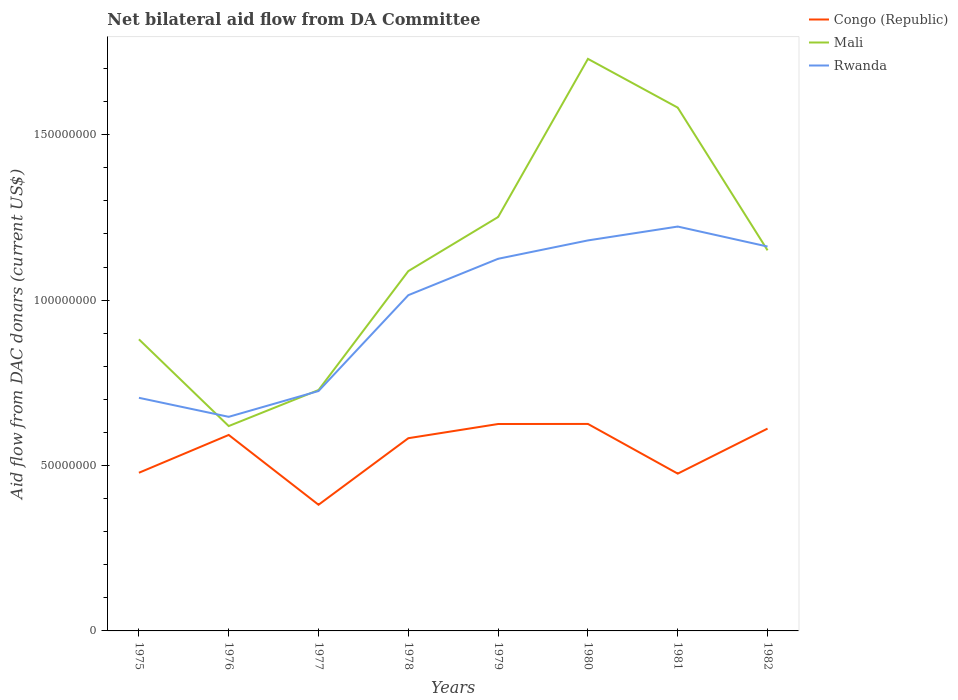Does the line corresponding to Mali intersect with the line corresponding to Rwanda?
Provide a short and direct response. Yes. Is the number of lines equal to the number of legend labels?
Your response must be concise. Yes. Across all years, what is the maximum aid flow in in Mali?
Your answer should be compact. 6.19e+07. In which year was the aid flow in in Congo (Republic) maximum?
Keep it short and to the point. 1977. What is the total aid flow in in Congo (Republic) in the graph?
Give a very brief answer. 2.11e+07. What is the difference between the highest and the second highest aid flow in in Mali?
Ensure brevity in your answer.  1.11e+08. What is the difference between the highest and the lowest aid flow in in Congo (Republic)?
Your answer should be very brief. 5. How many lines are there?
Your answer should be very brief. 3. What is the difference between two consecutive major ticks on the Y-axis?
Offer a very short reply. 5.00e+07. Are the values on the major ticks of Y-axis written in scientific E-notation?
Give a very brief answer. No. Does the graph contain grids?
Keep it short and to the point. No. What is the title of the graph?
Your answer should be compact. Net bilateral aid flow from DA Committee. Does "Sri Lanka" appear as one of the legend labels in the graph?
Your answer should be very brief. No. What is the label or title of the Y-axis?
Ensure brevity in your answer.  Aid flow from DAC donars (current US$). What is the Aid flow from DAC donars (current US$) in Congo (Republic) in 1975?
Give a very brief answer. 4.78e+07. What is the Aid flow from DAC donars (current US$) of Mali in 1975?
Offer a very short reply. 8.82e+07. What is the Aid flow from DAC donars (current US$) of Rwanda in 1975?
Give a very brief answer. 7.05e+07. What is the Aid flow from DAC donars (current US$) in Congo (Republic) in 1976?
Your answer should be compact. 5.92e+07. What is the Aid flow from DAC donars (current US$) in Mali in 1976?
Keep it short and to the point. 6.19e+07. What is the Aid flow from DAC donars (current US$) of Rwanda in 1976?
Your answer should be compact. 6.47e+07. What is the Aid flow from DAC donars (current US$) of Congo (Republic) in 1977?
Offer a very short reply. 3.81e+07. What is the Aid flow from DAC donars (current US$) of Mali in 1977?
Give a very brief answer. 7.28e+07. What is the Aid flow from DAC donars (current US$) of Rwanda in 1977?
Your response must be concise. 7.25e+07. What is the Aid flow from DAC donars (current US$) in Congo (Republic) in 1978?
Offer a terse response. 5.83e+07. What is the Aid flow from DAC donars (current US$) in Mali in 1978?
Your answer should be compact. 1.09e+08. What is the Aid flow from DAC donars (current US$) in Rwanda in 1978?
Offer a very short reply. 1.02e+08. What is the Aid flow from DAC donars (current US$) of Congo (Republic) in 1979?
Offer a terse response. 6.26e+07. What is the Aid flow from DAC donars (current US$) of Mali in 1979?
Make the answer very short. 1.25e+08. What is the Aid flow from DAC donars (current US$) of Rwanda in 1979?
Make the answer very short. 1.12e+08. What is the Aid flow from DAC donars (current US$) of Congo (Republic) in 1980?
Keep it short and to the point. 6.26e+07. What is the Aid flow from DAC donars (current US$) in Mali in 1980?
Your answer should be compact. 1.73e+08. What is the Aid flow from DAC donars (current US$) in Rwanda in 1980?
Offer a terse response. 1.18e+08. What is the Aid flow from DAC donars (current US$) of Congo (Republic) in 1981?
Give a very brief answer. 4.76e+07. What is the Aid flow from DAC donars (current US$) in Mali in 1981?
Offer a terse response. 1.58e+08. What is the Aid flow from DAC donars (current US$) in Rwanda in 1981?
Give a very brief answer. 1.22e+08. What is the Aid flow from DAC donars (current US$) in Congo (Republic) in 1982?
Your answer should be very brief. 6.12e+07. What is the Aid flow from DAC donars (current US$) in Mali in 1982?
Give a very brief answer. 1.15e+08. What is the Aid flow from DAC donars (current US$) in Rwanda in 1982?
Your answer should be compact. 1.16e+08. Across all years, what is the maximum Aid flow from DAC donars (current US$) of Congo (Republic)?
Provide a short and direct response. 6.26e+07. Across all years, what is the maximum Aid flow from DAC donars (current US$) in Mali?
Your response must be concise. 1.73e+08. Across all years, what is the maximum Aid flow from DAC donars (current US$) of Rwanda?
Ensure brevity in your answer.  1.22e+08. Across all years, what is the minimum Aid flow from DAC donars (current US$) in Congo (Republic)?
Make the answer very short. 3.81e+07. Across all years, what is the minimum Aid flow from DAC donars (current US$) of Mali?
Give a very brief answer. 6.19e+07. Across all years, what is the minimum Aid flow from DAC donars (current US$) in Rwanda?
Your answer should be compact. 6.47e+07. What is the total Aid flow from DAC donars (current US$) of Congo (Republic) in the graph?
Make the answer very short. 4.37e+08. What is the total Aid flow from DAC donars (current US$) of Mali in the graph?
Provide a succinct answer. 9.03e+08. What is the total Aid flow from DAC donars (current US$) in Rwanda in the graph?
Provide a succinct answer. 7.78e+08. What is the difference between the Aid flow from DAC donars (current US$) of Congo (Republic) in 1975 and that in 1976?
Ensure brevity in your answer.  -1.14e+07. What is the difference between the Aid flow from DAC donars (current US$) of Mali in 1975 and that in 1976?
Ensure brevity in your answer.  2.62e+07. What is the difference between the Aid flow from DAC donars (current US$) of Rwanda in 1975 and that in 1976?
Ensure brevity in your answer.  5.75e+06. What is the difference between the Aid flow from DAC donars (current US$) in Congo (Republic) in 1975 and that in 1977?
Your response must be concise. 9.67e+06. What is the difference between the Aid flow from DAC donars (current US$) of Mali in 1975 and that in 1977?
Give a very brief answer. 1.53e+07. What is the difference between the Aid flow from DAC donars (current US$) of Rwanda in 1975 and that in 1977?
Offer a terse response. -2.05e+06. What is the difference between the Aid flow from DAC donars (current US$) in Congo (Republic) in 1975 and that in 1978?
Make the answer very short. -1.04e+07. What is the difference between the Aid flow from DAC donars (current US$) in Mali in 1975 and that in 1978?
Your answer should be compact. -2.06e+07. What is the difference between the Aid flow from DAC donars (current US$) in Rwanda in 1975 and that in 1978?
Give a very brief answer. -3.10e+07. What is the difference between the Aid flow from DAC donars (current US$) in Congo (Republic) in 1975 and that in 1979?
Offer a very short reply. -1.47e+07. What is the difference between the Aid flow from DAC donars (current US$) in Mali in 1975 and that in 1979?
Give a very brief answer. -3.70e+07. What is the difference between the Aid flow from DAC donars (current US$) of Rwanda in 1975 and that in 1979?
Offer a very short reply. -4.20e+07. What is the difference between the Aid flow from DAC donars (current US$) in Congo (Republic) in 1975 and that in 1980?
Make the answer very short. -1.48e+07. What is the difference between the Aid flow from DAC donars (current US$) of Mali in 1975 and that in 1980?
Ensure brevity in your answer.  -8.48e+07. What is the difference between the Aid flow from DAC donars (current US$) of Rwanda in 1975 and that in 1980?
Provide a short and direct response. -4.76e+07. What is the difference between the Aid flow from DAC donars (current US$) in Mali in 1975 and that in 1981?
Offer a terse response. -7.00e+07. What is the difference between the Aid flow from DAC donars (current US$) in Rwanda in 1975 and that in 1981?
Ensure brevity in your answer.  -5.18e+07. What is the difference between the Aid flow from DAC donars (current US$) of Congo (Republic) in 1975 and that in 1982?
Keep it short and to the point. -1.34e+07. What is the difference between the Aid flow from DAC donars (current US$) of Mali in 1975 and that in 1982?
Your answer should be compact. -2.69e+07. What is the difference between the Aid flow from DAC donars (current US$) of Rwanda in 1975 and that in 1982?
Your response must be concise. -4.57e+07. What is the difference between the Aid flow from DAC donars (current US$) in Congo (Republic) in 1976 and that in 1977?
Provide a succinct answer. 2.11e+07. What is the difference between the Aid flow from DAC donars (current US$) in Mali in 1976 and that in 1977?
Your answer should be very brief. -1.09e+07. What is the difference between the Aid flow from DAC donars (current US$) of Rwanda in 1976 and that in 1977?
Keep it short and to the point. -7.80e+06. What is the difference between the Aid flow from DAC donars (current US$) in Congo (Republic) in 1976 and that in 1978?
Your answer should be very brief. 9.80e+05. What is the difference between the Aid flow from DAC donars (current US$) of Mali in 1976 and that in 1978?
Give a very brief answer. -4.68e+07. What is the difference between the Aid flow from DAC donars (current US$) of Rwanda in 1976 and that in 1978?
Provide a short and direct response. -3.68e+07. What is the difference between the Aid flow from DAC donars (current US$) in Congo (Republic) in 1976 and that in 1979?
Make the answer very short. -3.31e+06. What is the difference between the Aid flow from DAC donars (current US$) in Mali in 1976 and that in 1979?
Provide a succinct answer. -6.32e+07. What is the difference between the Aid flow from DAC donars (current US$) in Rwanda in 1976 and that in 1979?
Offer a terse response. -4.78e+07. What is the difference between the Aid flow from DAC donars (current US$) in Congo (Republic) in 1976 and that in 1980?
Make the answer very short. -3.33e+06. What is the difference between the Aid flow from DAC donars (current US$) in Mali in 1976 and that in 1980?
Offer a terse response. -1.11e+08. What is the difference between the Aid flow from DAC donars (current US$) of Rwanda in 1976 and that in 1980?
Your answer should be very brief. -5.33e+07. What is the difference between the Aid flow from DAC donars (current US$) in Congo (Republic) in 1976 and that in 1981?
Offer a terse response. 1.17e+07. What is the difference between the Aid flow from DAC donars (current US$) in Mali in 1976 and that in 1981?
Make the answer very short. -9.63e+07. What is the difference between the Aid flow from DAC donars (current US$) of Rwanda in 1976 and that in 1981?
Your response must be concise. -5.75e+07. What is the difference between the Aid flow from DAC donars (current US$) in Congo (Republic) in 1976 and that in 1982?
Provide a short and direct response. -1.92e+06. What is the difference between the Aid flow from DAC donars (current US$) of Mali in 1976 and that in 1982?
Your answer should be compact. -5.31e+07. What is the difference between the Aid flow from DAC donars (current US$) in Rwanda in 1976 and that in 1982?
Make the answer very short. -5.15e+07. What is the difference between the Aid flow from DAC donars (current US$) in Congo (Republic) in 1977 and that in 1978?
Ensure brevity in your answer.  -2.01e+07. What is the difference between the Aid flow from DAC donars (current US$) of Mali in 1977 and that in 1978?
Your answer should be very brief. -3.60e+07. What is the difference between the Aid flow from DAC donars (current US$) of Rwanda in 1977 and that in 1978?
Provide a succinct answer. -2.90e+07. What is the difference between the Aid flow from DAC donars (current US$) in Congo (Republic) in 1977 and that in 1979?
Make the answer very short. -2.44e+07. What is the difference between the Aid flow from DAC donars (current US$) of Mali in 1977 and that in 1979?
Provide a succinct answer. -5.23e+07. What is the difference between the Aid flow from DAC donars (current US$) of Rwanda in 1977 and that in 1979?
Offer a very short reply. -4.00e+07. What is the difference between the Aid flow from DAC donars (current US$) of Congo (Republic) in 1977 and that in 1980?
Make the answer very short. -2.44e+07. What is the difference between the Aid flow from DAC donars (current US$) of Mali in 1977 and that in 1980?
Ensure brevity in your answer.  -1.00e+08. What is the difference between the Aid flow from DAC donars (current US$) of Rwanda in 1977 and that in 1980?
Provide a short and direct response. -4.55e+07. What is the difference between the Aid flow from DAC donars (current US$) in Congo (Republic) in 1977 and that in 1981?
Your response must be concise. -9.41e+06. What is the difference between the Aid flow from DAC donars (current US$) in Mali in 1977 and that in 1981?
Offer a terse response. -8.54e+07. What is the difference between the Aid flow from DAC donars (current US$) in Rwanda in 1977 and that in 1981?
Offer a very short reply. -4.97e+07. What is the difference between the Aid flow from DAC donars (current US$) in Congo (Republic) in 1977 and that in 1982?
Keep it short and to the point. -2.30e+07. What is the difference between the Aid flow from DAC donars (current US$) in Mali in 1977 and that in 1982?
Offer a very short reply. -4.22e+07. What is the difference between the Aid flow from DAC donars (current US$) of Rwanda in 1977 and that in 1982?
Provide a succinct answer. -4.37e+07. What is the difference between the Aid flow from DAC donars (current US$) in Congo (Republic) in 1978 and that in 1979?
Your response must be concise. -4.29e+06. What is the difference between the Aid flow from DAC donars (current US$) in Mali in 1978 and that in 1979?
Offer a terse response. -1.64e+07. What is the difference between the Aid flow from DAC donars (current US$) in Rwanda in 1978 and that in 1979?
Give a very brief answer. -1.10e+07. What is the difference between the Aid flow from DAC donars (current US$) of Congo (Republic) in 1978 and that in 1980?
Your response must be concise. -4.31e+06. What is the difference between the Aid flow from DAC donars (current US$) of Mali in 1978 and that in 1980?
Offer a terse response. -6.42e+07. What is the difference between the Aid flow from DAC donars (current US$) of Rwanda in 1978 and that in 1980?
Give a very brief answer. -1.66e+07. What is the difference between the Aid flow from DAC donars (current US$) of Congo (Republic) in 1978 and that in 1981?
Offer a very short reply. 1.07e+07. What is the difference between the Aid flow from DAC donars (current US$) in Mali in 1978 and that in 1981?
Ensure brevity in your answer.  -4.94e+07. What is the difference between the Aid flow from DAC donars (current US$) of Rwanda in 1978 and that in 1981?
Make the answer very short. -2.07e+07. What is the difference between the Aid flow from DAC donars (current US$) of Congo (Republic) in 1978 and that in 1982?
Your answer should be very brief. -2.90e+06. What is the difference between the Aid flow from DAC donars (current US$) of Mali in 1978 and that in 1982?
Offer a terse response. -6.27e+06. What is the difference between the Aid flow from DAC donars (current US$) in Rwanda in 1978 and that in 1982?
Offer a very short reply. -1.47e+07. What is the difference between the Aid flow from DAC donars (current US$) in Mali in 1979 and that in 1980?
Offer a terse response. -4.78e+07. What is the difference between the Aid flow from DAC donars (current US$) in Rwanda in 1979 and that in 1980?
Your response must be concise. -5.55e+06. What is the difference between the Aid flow from DAC donars (current US$) of Congo (Republic) in 1979 and that in 1981?
Give a very brief answer. 1.50e+07. What is the difference between the Aid flow from DAC donars (current US$) of Mali in 1979 and that in 1981?
Your response must be concise. -3.31e+07. What is the difference between the Aid flow from DAC donars (current US$) of Rwanda in 1979 and that in 1981?
Ensure brevity in your answer.  -9.74e+06. What is the difference between the Aid flow from DAC donars (current US$) of Congo (Republic) in 1979 and that in 1982?
Your response must be concise. 1.39e+06. What is the difference between the Aid flow from DAC donars (current US$) in Mali in 1979 and that in 1982?
Your response must be concise. 1.01e+07. What is the difference between the Aid flow from DAC donars (current US$) of Rwanda in 1979 and that in 1982?
Make the answer very short. -3.70e+06. What is the difference between the Aid flow from DAC donars (current US$) of Congo (Republic) in 1980 and that in 1981?
Your response must be concise. 1.50e+07. What is the difference between the Aid flow from DAC donars (current US$) in Mali in 1980 and that in 1981?
Ensure brevity in your answer.  1.47e+07. What is the difference between the Aid flow from DAC donars (current US$) in Rwanda in 1980 and that in 1981?
Your response must be concise. -4.19e+06. What is the difference between the Aid flow from DAC donars (current US$) of Congo (Republic) in 1980 and that in 1982?
Your answer should be compact. 1.41e+06. What is the difference between the Aid flow from DAC donars (current US$) in Mali in 1980 and that in 1982?
Keep it short and to the point. 5.79e+07. What is the difference between the Aid flow from DAC donars (current US$) in Rwanda in 1980 and that in 1982?
Provide a short and direct response. 1.85e+06. What is the difference between the Aid flow from DAC donars (current US$) in Congo (Republic) in 1981 and that in 1982?
Provide a succinct answer. -1.36e+07. What is the difference between the Aid flow from DAC donars (current US$) of Mali in 1981 and that in 1982?
Make the answer very short. 4.31e+07. What is the difference between the Aid flow from DAC donars (current US$) of Rwanda in 1981 and that in 1982?
Give a very brief answer. 6.04e+06. What is the difference between the Aid flow from DAC donars (current US$) in Congo (Republic) in 1975 and the Aid flow from DAC donars (current US$) in Mali in 1976?
Offer a terse response. -1.41e+07. What is the difference between the Aid flow from DAC donars (current US$) of Congo (Republic) in 1975 and the Aid flow from DAC donars (current US$) of Rwanda in 1976?
Give a very brief answer. -1.69e+07. What is the difference between the Aid flow from DAC donars (current US$) in Mali in 1975 and the Aid flow from DAC donars (current US$) in Rwanda in 1976?
Your answer should be very brief. 2.34e+07. What is the difference between the Aid flow from DAC donars (current US$) in Congo (Republic) in 1975 and the Aid flow from DAC donars (current US$) in Mali in 1977?
Give a very brief answer. -2.50e+07. What is the difference between the Aid flow from DAC donars (current US$) of Congo (Republic) in 1975 and the Aid flow from DAC donars (current US$) of Rwanda in 1977?
Your answer should be very brief. -2.47e+07. What is the difference between the Aid flow from DAC donars (current US$) of Mali in 1975 and the Aid flow from DAC donars (current US$) of Rwanda in 1977?
Provide a short and direct response. 1.56e+07. What is the difference between the Aid flow from DAC donars (current US$) in Congo (Republic) in 1975 and the Aid flow from DAC donars (current US$) in Mali in 1978?
Your answer should be very brief. -6.10e+07. What is the difference between the Aid flow from DAC donars (current US$) in Congo (Republic) in 1975 and the Aid flow from DAC donars (current US$) in Rwanda in 1978?
Keep it short and to the point. -5.37e+07. What is the difference between the Aid flow from DAC donars (current US$) in Mali in 1975 and the Aid flow from DAC donars (current US$) in Rwanda in 1978?
Your response must be concise. -1.34e+07. What is the difference between the Aid flow from DAC donars (current US$) in Congo (Republic) in 1975 and the Aid flow from DAC donars (current US$) in Mali in 1979?
Keep it short and to the point. -7.73e+07. What is the difference between the Aid flow from DAC donars (current US$) in Congo (Republic) in 1975 and the Aid flow from DAC donars (current US$) in Rwanda in 1979?
Ensure brevity in your answer.  -6.47e+07. What is the difference between the Aid flow from DAC donars (current US$) of Mali in 1975 and the Aid flow from DAC donars (current US$) of Rwanda in 1979?
Keep it short and to the point. -2.44e+07. What is the difference between the Aid flow from DAC donars (current US$) in Congo (Republic) in 1975 and the Aid flow from DAC donars (current US$) in Mali in 1980?
Your response must be concise. -1.25e+08. What is the difference between the Aid flow from DAC donars (current US$) in Congo (Republic) in 1975 and the Aid flow from DAC donars (current US$) in Rwanda in 1980?
Your response must be concise. -7.02e+07. What is the difference between the Aid flow from DAC donars (current US$) in Mali in 1975 and the Aid flow from DAC donars (current US$) in Rwanda in 1980?
Offer a terse response. -2.99e+07. What is the difference between the Aid flow from DAC donars (current US$) of Congo (Republic) in 1975 and the Aid flow from DAC donars (current US$) of Mali in 1981?
Provide a short and direct response. -1.10e+08. What is the difference between the Aid flow from DAC donars (current US$) of Congo (Republic) in 1975 and the Aid flow from DAC donars (current US$) of Rwanda in 1981?
Your response must be concise. -7.44e+07. What is the difference between the Aid flow from DAC donars (current US$) of Mali in 1975 and the Aid flow from DAC donars (current US$) of Rwanda in 1981?
Give a very brief answer. -3.41e+07. What is the difference between the Aid flow from DAC donars (current US$) in Congo (Republic) in 1975 and the Aid flow from DAC donars (current US$) in Mali in 1982?
Keep it short and to the point. -6.72e+07. What is the difference between the Aid flow from DAC donars (current US$) in Congo (Republic) in 1975 and the Aid flow from DAC donars (current US$) in Rwanda in 1982?
Offer a very short reply. -6.84e+07. What is the difference between the Aid flow from DAC donars (current US$) of Mali in 1975 and the Aid flow from DAC donars (current US$) of Rwanda in 1982?
Offer a very short reply. -2.80e+07. What is the difference between the Aid flow from DAC donars (current US$) of Congo (Republic) in 1976 and the Aid flow from DAC donars (current US$) of Mali in 1977?
Provide a succinct answer. -1.36e+07. What is the difference between the Aid flow from DAC donars (current US$) of Congo (Republic) in 1976 and the Aid flow from DAC donars (current US$) of Rwanda in 1977?
Provide a succinct answer. -1.33e+07. What is the difference between the Aid flow from DAC donars (current US$) of Mali in 1976 and the Aid flow from DAC donars (current US$) of Rwanda in 1977?
Offer a terse response. -1.06e+07. What is the difference between the Aid flow from DAC donars (current US$) of Congo (Republic) in 1976 and the Aid flow from DAC donars (current US$) of Mali in 1978?
Offer a terse response. -4.95e+07. What is the difference between the Aid flow from DAC donars (current US$) of Congo (Republic) in 1976 and the Aid flow from DAC donars (current US$) of Rwanda in 1978?
Keep it short and to the point. -4.23e+07. What is the difference between the Aid flow from DAC donars (current US$) in Mali in 1976 and the Aid flow from DAC donars (current US$) in Rwanda in 1978?
Offer a very short reply. -3.96e+07. What is the difference between the Aid flow from DAC donars (current US$) in Congo (Republic) in 1976 and the Aid flow from DAC donars (current US$) in Mali in 1979?
Provide a succinct answer. -6.59e+07. What is the difference between the Aid flow from DAC donars (current US$) of Congo (Republic) in 1976 and the Aid flow from DAC donars (current US$) of Rwanda in 1979?
Your response must be concise. -5.33e+07. What is the difference between the Aid flow from DAC donars (current US$) in Mali in 1976 and the Aid flow from DAC donars (current US$) in Rwanda in 1979?
Offer a very short reply. -5.06e+07. What is the difference between the Aid flow from DAC donars (current US$) in Congo (Republic) in 1976 and the Aid flow from DAC donars (current US$) in Mali in 1980?
Keep it short and to the point. -1.14e+08. What is the difference between the Aid flow from DAC donars (current US$) of Congo (Republic) in 1976 and the Aid flow from DAC donars (current US$) of Rwanda in 1980?
Your answer should be compact. -5.88e+07. What is the difference between the Aid flow from DAC donars (current US$) of Mali in 1976 and the Aid flow from DAC donars (current US$) of Rwanda in 1980?
Provide a short and direct response. -5.61e+07. What is the difference between the Aid flow from DAC donars (current US$) in Congo (Republic) in 1976 and the Aid flow from DAC donars (current US$) in Mali in 1981?
Provide a succinct answer. -9.90e+07. What is the difference between the Aid flow from DAC donars (current US$) in Congo (Republic) in 1976 and the Aid flow from DAC donars (current US$) in Rwanda in 1981?
Give a very brief answer. -6.30e+07. What is the difference between the Aid flow from DAC donars (current US$) of Mali in 1976 and the Aid flow from DAC donars (current US$) of Rwanda in 1981?
Offer a very short reply. -6.03e+07. What is the difference between the Aid flow from DAC donars (current US$) of Congo (Republic) in 1976 and the Aid flow from DAC donars (current US$) of Mali in 1982?
Offer a very short reply. -5.58e+07. What is the difference between the Aid flow from DAC donars (current US$) of Congo (Republic) in 1976 and the Aid flow from DAC donars (current US$) of Rwanda in 1982?
Give a very brief answer. -5.70e+07. What is the difference between the Aid flow from DAC donars (current US$) of Mali in 1976 and the Aid flow from DAC donars (current US$) of Rwanda in 1982?
Offer a very short reply. -5.43e+07. What is the difference between the Aid flow from DAC donars (current US$) in Congo (Republic) in 1977 and the Aid flow from DAC donars (current US$) in Mali in 1978?
Your answer should be compact. -7.06e+07. What is the difference between the Aid flow from DAC donars (current US$) of Congo (Republic) in 1977 and the Aid flow from DAC donars (current US$) of Rwanda in 1978?
Provide a succinct answer. -6.34e+07. What is the difference between the Aid flow from DAC donars (current US$) in Mali in 1977 and the Aid flow from DAC donars (current US$) in Rwanda in 1978?
Keep it short and to the point. -2.87e+07. What is the difference between the Aid flow from DAC donars (current US$) of Congo (Republic) in 1977 and the Aid flow from DAC donars (current US$) of Mali in 1979?
Keep it short and to the point. -8.70e+07. What is the difference between the Aid flow from DAC donars (current US$) of Congo (Republic) in 1977 and the Aid flow from DAC donars (current US$) of Rwanda in 1979?
Offer a very short reply. -7.44e+07. What is the difference between the Aid flow from DAC donars (current US$) of Mali in 1977 and the Aid flow from DAC donars (current US$) of Rwanda in 1979?
Ensure brevity in your answer.  -3.97e+07. What is the difference between the Aid flow from DAC donars (current US$) in Congo (Republic) in 1977 and the Aid flow from DAC donars (current US$) in Mali in 1980?
Your response must be concise. -1.35e+08. What is the difference between the Aid flow from DAC donars (current US$) in Congo (Republic) in 1977 and the Aid flow from DAC donars (current US$) in Rwanda in 1980?
Keep it short and to the point. -7.99e+07. What is the difference between the Aid flow from DAC donars (current US$) in Mali in 1977 and the Aid flow from DAC donars (current US$) in Rwanda in 1980?
Ensure brevity in your answer.  -4.52e+07. What is the difference between the Aid flow from DAC donars (current US$) in Congo (Republic) in 1977 and the Aid flow from DAC donars (current US$) in Mali in 1981?
Provide a succinct answer. -1.20e+08. What is the difference between the Aid flow from DAC donars (current US$) in Congo (Republic) in 1977 and the Aid flow from DAC donars (current US$) in Rwanda in 1981?
Make the answer very short. -8.41e+07. What is the difference between the Aid flow from DAC donars (current US$) of Mali in 1977 and the Aid flow from DAC donars (current US$) of Rwanda in 1981?
Offer a very short reply. -4.94e+07. What is the difference between the Aid flow from DAC donars (current US$) in Congo (Republic) in 1977 and the Aid flow from DAC donars (current US$) in Mali in 1982?
Your response must be concise. -7.69e+07. What is the difference between the Aid flow from DAC donars (current US$) of Congo (Republic) in 1977 and the Aid flow from DAC donars (current US$) of Rwanda in 1982?
Offer a terse response. -7.81e+07. What is the difference between the Aid flow from DAC donars (current US$) of Mali in 1977 and the Aid flow from DAC donars (current US$) of Rwanda in 1982?
Offer a terse response. -4.34e+07. What is the difference between the Aid flow from DAC donars (current US$) of Congo (Republic) in 1978 and the Aid flow from DAC donars (current US$) of Mali in 1979?
Make the answer very short. -6.69e+07. What is the difference between the Aid flow from DAC donars (current US$) in Congo (Republic) in 1978 and the Aid flow from DAC donars (current US$) in Rwanda in 1979?
Give a very brief answer. -5.42e+07. What is the difference between the Aid flow from DAC donars (current US$) of Mali in 1978 and the Aid flow from DAC donars (current US$) of Rwanda in 1979?
Ensure brevity in your answer.  -3.72e+06. What is the difference between the Aid flow from DAC donars (current US$) of Congo (Republic) in 1978 and the Aid flow from DAC donars (current US$) of Mali in 1980?
Offer a very short reply. -1.15e+08. What is the difference between the Aid flow from DAC donars (current US$) in Congo (Republic) in 1978 and the Aid flow from DAC donars (current US$) in Rwanda in 1980?
Ensure brevity in your answer.  -5.98e+07. What is the difference between the Aid flow from DAC donars (current US$) of Mali in 1978 and the Aid flow from DAC donars (current US$) of Rwanda in 1980?
Make the answer very short. -9.27e+06. What is the difference between the Aid flow from DAC donars (current US$) in Congo (Republic) in 1978 and the Aid flow from DAC donars (current US$) in Mali in 1981?
Your answer should be compact. -9.99e+07. What is the difference between the Aid flow from DAC donars (current US$) in Congo (Republic) in 1978 and the Aid flow from DAC donars (current US$) in Rwanda in 1981?
Ensure brevity in your answer.  -6.40e+07. What is the difference between the Aid flow from DAC donars (current US$) in Mali in 1978 and the Aid flow from DAC donars (current US$) in Rwanda in 1981?
Offer a very short reply. -1.35e+07. What is the difference between the Aid flow from DAC donars (current US$) in Congo (Republic) in 1978 and the Aid flow from DAC donars (current US$) in Mali in 1982?
Provide a short and direct response. -5.68e+07. What is the difference between the Aid flow from DAC donars (current US$) in Congo (Republic) in 1978 and the Aid flow from DAC donars (current US$) in Rwanda in 1982?
Keep it short and to the point. -5.79e+07. What is the difference between the Aid flow from DAC donars (current US$) in Mali in 1978 and the Aid flow from DAC donars (current US$) in Rwanda in 1982?
Offer a very short reply. -7.42e+06. What is the difference between the Aid flow from DAC donars (current US$) in Congo (Republic) in 1979 and the Aid flow from DAC donars (current US$) in Mali in 1980?
Offer a very short reply. -1.10e+08. What is the difference between the Aid flow from DAC donars (current US$) of Congo (Republic) in 1979 and the Aid flow from DAC donars (current US$) of Rwanda in 1980?
Provide a short and direct response. -5.55e+07. What is the difference between the Aid flow from DAC donars (current US$) of Mali in 1979 and the Aid flow from DAC donars (current US$) of Rwanda in 1980?
Ensure brevity in your answer.  7.08e+06. What is the difference between the Aid flow from DAC donars (current US$) in Congo (Republic) in 1979 and the Aid flow from DAC donars (current US$) in Mali in 1981?
Your response must be concise. -9.56e+07. What is the difference between the Aid flow from DAC donars (current US$) of Congo (Republic) in 1979 and the Aid flow from DAC donars (current US$) of Rwanda in 1981?
Your answer should be very brief. -5.97e+07. What is the difference between the Aid flow from DAC donars (current US$) in Mali in 1979 and the Aid flow from DAC donars (current US$) in Rwanda in 1981?
Offer a very short reply. 2.89e+06. What is the difference between the Aid flow from DAC donars (current US$) of Congo (Republic) in 1979 and the Aid flow from DAC donars (current US$) of Mali in 1982?
Keep it short and to the point. -5.25e+07. What is the difference between the Aid flow from DAC donars (current US$) of Congo (Republic) in 1979 and the Aid flow from DAC donars (current US$) of Rwanda in 1982?
Make the answer very short. -5.36e+07. What is the difference between the Aid flow from DAC donars (current US$) in Mali in 1979 and the Aid flow from DAC donars (current US$) in Rwanda in 1982?
Your response must be concise. 8.93e+06. What is the difference between the Aid flow from DAC donars (current US$) in Congo (Republic) in 1980 and the Aid flow from DAC donars (current US$) in Mali in 1981?
Keep it short and to the point. -9.56e+07. What is the difference between the Aid flow from DAC donars (current US$) of Congo (Republic) in 1980 and the Aid flow from DAC donars (current US$) of Rwanda in 1981?
Offer a very short reply. -5.97e+07. What is the difference between the Aid flow from DAC donars (current US$) in Mali in 1980 and the Aid flow from DAC donars (current US$) in Rwanda in 1981?
Your answer should be compact. 5.07e+07. What is the difference between the Aid flow from DAC donars (current US$) of Congo (Republic) in 1980 and the Aid flow from DAC donars (current US$) of Mali in 1982?
Your answer should be compact. -5.25e+07. What is the difference between the Aid flow from DAC donars (current US$) in Congo (Republic) in 1980 and the Aid flow from DAC donars (current US$) in Rwanda in 1982?
Your response must be concise. -5.36e+07. What is the difference between the Aid flow from DAC donars (current US$) of Mali in 1980 and the Aid flow from DAC donars (current US$) of Rwanda in 1982?
Your answer should be very brief. 5.67e+07. What is the difference between the Aid flow from DAC donars (current US$) in Congo (Republic) in 1981 and the Aid flow from DAC donars (current US$) in Mali in 1982?
Provide a succinct answer. -6.75e+07. What is the difference between the Aid flow from DAC donars (current US$) of Congo (Republic) in 1981 and the Aid flow from DAC donars (current US$) of Rwanda in 1982?
Provide a short and direct response. -6.86e+07. What is the difference between the Aid flow from DAC donars (current US$) of Mali in 1981 and the Aid flow from DAC donars (current US$) of Rwanda in 1982?
Give a very brief answer. 4.20e+07. What is the average Aid flow from DAC donars (current US$) of Congo (Republic) per year?
Keep it short and to the point. 5.47e+07. What is the average Aid flow from DAC donars (current US$) of Mali per year?
Make the answer very short. 1.13e+08. What is the average Aid flow from DAC donars (current US$) in Rwanda per year?
Ensure brevity in your answer.  9.73e+07. In the year 1975, what is the difference between the Aid flow from DAC donars (current US$) in Congo (Republic) and Aid flow from DAC donars (current US$) in Mali?
Your answer should be very brief. -4.03e+07. In the year 1975, what is the difference between the Aid flow from DAC donars (current US$) in Congo (Republic) and Aid flow from DAC donars (current US$) in Rwanda?
Give a very brief answer. -2.27e+07. In the year 1975, what is the difference between the Aid flow from DAC donars (current US$) of Mali and Aid flow from DAC donars (current US$) of Rwanda?
Give a very brief answer. 1.77e+07. In the year 1976, what is the difference between the Aid flow from DAC donars (current US$) of Congo (Republic) and Aid flow from DAC donars (current US$) of Mali?
Ensure brevity in your answer.  -2.69e+06. In the year 1976, what is the difference between the Aid flow from DAC donars (current US$) of Congo (Republic) and Aid flow from DAC donars (current US$) of Rwanda?
Offer a terse response. -5.48e+06. In the year 1976, what is the difference between the Aid flow from DAC donars (current US$) in Mali and Aid flow from DAC donars (current US$) in Rwanda?
Offer a terse response. -2.79e+06. In the year 1977, what is the difference between the Aid flow from DAC donars (current US$) in Congo (Republic) and Aid flow from DAC donars (current US$) in Mali?
Give a very brief answer. -3.47e+07. In the year 1977, what is the difference between the Aid flow from DAC donars (current US$) in Congo (Republic) and Aid flow from DAC donars (current US$) in Rwanda?
Provide a succinct answer. -3.44e+07. In the year 1978, what is the difference between the Aid flow from DAC donars (current US$) in Congo (Republic) and Aid flow from DAC donars (current US$) in Mali?
Give a very brief answer. -5.05e+07. In the year 1978, what is the difference between the Aid flow from DAC donars (current US$) in Congo (Republic) and Aid flow from DAC donars (current US$) in Rwanda?
Provide a short and direct response. -4.32e+07. In the year 1978, what is the difference between the Aid flow from DAC donars (current US$) of Mali and Aid flow from DAC donars (current US$) of Rwanda?
Keep it short and to the point. 7.28e+06. In the year 1979, what is the difference between the Aid flow from DAC donars (current US$) in Congo (Republic) and Aid flow from DAC donars (current US$) in Mali?
Your answer should be very brief. -6.26e+07. In the year 1979, what is the difference between the Aid flow from DAC donars (current US$) in Congo (Republic) and Aid flow from DAC donars (current US$) in Rwanda?
Make the answer very short. -5.00e+07. In the year 1979, what is the difference between the Aid flow from DAC donars (current US$) in Mali and Aid flow from DAC donars (current US$) in Rwanda?
Offer a terse response. 1.26e+07. In the year 1980, what is the difference between the Aid flow from DAC donars (current US$) of Congo (Republic) and Aid flow from DAC donars (current US$) of Mali?
Offer a very short reply. -1.10e+08. In the year 1980, what is the difference between the Aid flow from DAC donars (current US$) of Congo (Republic) and Aid flow from DAC donars (current US$) of Rwanda?
Provide a succinct answer. -5.55e+07. In the year 1980, what is the difference between the Aid flow from DAC donars (current US$) in Mali and Aid flow from DAC donars (current US$) in Rwanda?
Make the answer very short. 5.49e+07. In the year 1981, what is the difference between the Aid flow from DAC donars (current US$) in Congo (Republic) and Aid flow from DAC donars (current US$) in Mali?
Ensure brevity in your answer.  -1.11e+08. In the year 1981, what is the difference between the Aid flow from DAC donars (current US$) in Congo (Republic) and Aid flow from DAC donars (current US$) in Rwanda?
Keep it short and to the point. -7.47e+07. In the year 1981, what is the difference between the Aid flow from DAC donars (current US$) in Mali and Aid flow from DAC donars (current US$) in Rwanda?
Your answer should be very brief. 3.60e+07. In the year 1982, what is the difference between the Aid flow from DAC donars (current US$) in Congo (Republic) and Aid flow from DAC donars (current US$) in Mali?
Your answer should be very brief. -5.39e+07. In the year 1982, what is the difference between the Aid flow from DAC donars (current US$) of Congo (Republic) and Aid flow from DAC donars (current US$) of Rwanda?
Provide a short and direct response. -5.50e+07. In the year 1982, what is the difference between the Aid flow from DAC donars (current US$) of Mali and Aid flow from DAC donars (current US$) of Rwanda?
Your answer should be very brief. -1.15e+06. What is the ratio of the Aid flow from DAC donars (current US$) of Congo (Republic) in 1975 to that in 1976?
Make the answer very short. 0.81. What is the ratio of the Aid flow from DAC donars (current US$) of Mali in 1975 to that in 1976?
Provide a short and direct response. 1.42. What is the ratio of the Aid flow from DAC donars (current US$) of Rwanda in 1975 to that in 1976?
Provide a short and direct response. 1.09. What is the ratio of the Aid flow from DAC donars (current US$) of Congo (Republic) in 1975 to that in 1977?
Give a very brief answer. 1.25. What is the ratio of the Aid flow from DAC donars (current US$) in Mali in 1975 to that in 1977?
Provide a short and direct response. 1.21. What is the ratio of the Aid flow from DAC donars (current US$) in Rwanda in 1975 to that in 1977?
Make the answer very short. 0.97. What is the ratio of the Aid flow from DAC donars (current US$) in Congo (Republic) in 1975 to that in 1978?
Keep it short and to the point. 0.82. What is the ratio of the Aid flow from DAC donars (current US$) of Mali in 1975 to that in 1978?
Offer a very short reply. 0.81. What is the ratio of the Aid flow from DAC donars (current US$) in Rwanda in 1975 to that in 1978?
Your answer should be very brief. 0.69. What is the ratio of the Aid flow from DAC donars (current US$) in Congo (Republic) in 1975 to that in 1979?
Ensure brevity in your answer.  0.76. What is the ratio of the Aid flow from DAC donars (current US$) in Mali in 1975 to that in 1979?
Your answer should be compact. 0.7. What is the ratio of the Aid flow from DAC donars (current US$) of Rwanda in 1975 to that in 1979?
Provide a short and direct response. 0.63. What is the ratio of the Aid flow from DAC donars (current US$) in Congo (Republic) in 1975 to that in 1980?
Keep it short and to the point. 0.76. What is the ratio of the Aid flow from DAC donars (current US$) in Mali in 1975 to that in 1980?
Ensure brevity in your answer.  0.51. What is the ratio of the Aid flow from DAC donars (current US$) of Rwanda in 1975 to that in 1980?
Offer a terse response. 0.6. What is the ratio of the Aid flow from DAC donars (current US$) of Congo (Republic) in 1975 to that in 1981?
Your answer should be compact. 1.01. What is the ratio of the Aid flow from DAC donars (current US$) in Mali in 1975 to that in 1981?
Offer a very short reply. 0.56. What is the ratio of the Aid flow from DAC donars (current US$) of Rwanda in 1975 to that in 1981?
Give a very brief answer. 0.58. What is the ratio of the Aid flow from DAC donars (current US$) of Congo (Republic) in 1975 to that in 1982?
Ensure brevity in your answer.  0.78. What is the ratio of the Aid flow from DAC donars (current US$) in Mali in 1975 to that in 1982?
Your response must be concise. 0.77. What is the ratio of the Aid flow from DAC donars (current US$) of Rwanda in 1975 to that in 1982?
Ensure brevity in your answer.  0.61. What is the ratio of the Aid flow from DAC donars (current US$) of Congo (Republic) in 1976 to that in 1977?
Give a very brief answer. 1.55. What is the ratio of the Aid flow from DAC donars (current US$) of Mali in 1976 to that in 1977?
Your answer should be very brief. 0.85. What is the ratio of the Aid flow from DAC donars (current US$) of Rwanda in 1976 to that in 1977?
Provide a short and direct response. 0.89. What is the ratio of the Aid flow from DAC donars (current US$) in Congo (Republic) in 1976 to that in 1978?
Provide a succinct answer. 1.02. What is the ratio of the Aid flow from DAC donars (current US$) of Mali in 1976 to that in 1978?
Offer a terse response. 0.57. What is the ratio of the Aid flow from DAC donars (current US$) in Rwanda in 1976 to that in 1978?
Your response must be concise. 0.64. What is the ratio of the Aid flow from DAC donars (current US$) of Congo (Republic) in 1976 to that in 1979?
Give a very brief answer. 0.95. What is the ratio of the Aid flow from DAC donars (current US$) in Mali in 1976 to that in 1979?
Your response must be concise. 0.49. What is the ratio of the Aid flow from DAC donars (current US$) in Rwanda in 1976 to that in 1979?
Provide a short and direct response. 0.58. What is the ratio of the Aid flow from DAC donars (current US$) of Congo (Republic) in 1976 to that in 1980?
Keep it short and to the point. 0.95. What is the ratio of the Aid flow from DAC donars (current US$) of Mali in 1976 to that in 1980?
Keep it short and to the point. 0.36. What is the ratio of the Aid flow from DAC donars (current US$) of Rwanda in 1976 to that in 1980?
Your answer should be very brief. 0.55. What is the ratio of the Aid flow from DAC donars (current US$) of Congo (Republic) in 1976 to that in 1981?
Offer a terse response. 1.25. What is the ratio of the Aid flow from DAC donars (current US$) of Mali in 1976 to that in 1981?
Offer a terse response. 0.39. What is the ratio of the Aid flow from DAC donars (current US$) in Rwanda in 1976 to that in 1981?
Offer a very short reply. 0.53. What is the ratio of the Aid flow from DAC donars (current US$) in Congo (Republic) in 1976 to that in 1982?
Provide a succinct answer. 0.97. What is the ratio of the Aid flow from DAC donars (current US$) in Mali in 1976 to that in 1982?
Ensure brevity in your answer.  0.54. What is the ratio of the Aid flow from DAC donars (current US$) of Rwanda in 1976 to that in 1982?
Keep it short and to the point. 0.56. What is the ratio of the Aid flow from DAC donars (current US$) in Congo (Republic) in 1977 to that in 1978?
Your response must be concise. 0.65. What is the ratio of the Aid flow from DAC donars (current US$) of Mali in 1977 to that in 1978?
Make the answer very short. 0.67. What is the ratio of the Aid flow from DAC donars (current US$) in Rwanda in 1977 to that in 1978?
Keep it short and to the point. 0.71. What is the ratio of the Aid flow from DAC donars (current US$) of Congo (Republic) in 1977 to that in 1979?
Your answer should be compact. 0.61. What is the ratio of the Aid flow from DAC donars (current US$) of Mali in 1977 to that in 1979?
Offer a terse response. 0.58. What is the ratio of the Aid flow from DAC donars (current US$) in Rwanda in 1977 to that in 1979?
Provide a succinct answer. 0.64. What is the ratio of the Aid flow from DAC donars (current US$) in Congo (Republic) in 1977 to that in 1980?
Offer a very short reply. 0.61. What is the ratio of the Aid flow from DAC donars (current US$) in Mali in 1977 to that in 1980?
Make the answer very short. 0.42. What is the ratio of the Aid flow from DAC donars (current US$) of Rwanda in 1977 to that in 1980?
Your response must be concise. 0.61. What is the ratio of the Aid flow from DAC donars (current US$) in Congo (Republic) in 1977 to that in 1981?
Provide a short and direct response. 0.8. What is the ratio of the Aid flow from DAC donars (current US$) of Mali in 1977 to that in 1981?
Provide a short and direct response. 0.46. What is the ratio of the Aid flow from DAC donars (current US$) of Rwanda in 1977 to that in 1981?
Provide a short and direct response. 0.59. What is the ratio of the Aid flow from DAC donars (current US$) of Congo (Republic) in 1977 to that in 1982?
Offer a terse response. 0.62. What is the ratio of the Aid flow from DAC donars (current US$) in Mali in 1977 to that in 1982?
Make the answer very short. 0.63. What is the ratio of the Aid flow from DAC donars (current US$) of Rwanda in 1977 to that in 1982?
Ensure brevity in your answer.  0.62. What is the ratio of the Aid flow from DAC donars (current US$) of Congo (Republic) in 1978 to that in 1979?
Ensure brevity in your answer.  0.93. What is the ratio of the Aid flow from DAC donars (current US$) in Mali in 1978 to that in 1979?
Ensure brevity in your answer.  0.87. What is the ratio of the Aid flow from DAC donars (current US$) in Rwanda in 1978 to that in 1979?
Keep it short and to the point. 0.9. What is the ratio of the Aid flow from DAC donars (current US$) of Congo (Republic) in 1978 to that in 1980?
Your answer should be compact. 0.93. What is the ratio of the Aid flow from DAC donars (current US$) of Mali in 1978 to that in 1980?
Give a very brief answer. 0.63. What is the ratio of the Aid flow from DAC donars (current US$) in Rwanda in 1978 to that in 1980?
Give a very brief answer. 0.86. What is the ratio of the Aid flow from DAC donars (current US$) in Congo (Republic) in 1978 to that in 1981?
Your answer should be compact. 1.23. What is the ratio of the Aid flow from DAC donars (current US$) of Mali in 1978 to that in 1981?
Your answer should be compact. 0.69. What is the ratio of the Aid flow from DAC donars (current US$) of Rwanda in 1978 to that in 1981?
Provide a short and direct response. 0.83. What is the ratio of the Aid flow from DAC donars (current US$) in Congo (Republic) in 1978 to that in 1982?
Your answer should be very brief. 0.95. What is the ratio of the Aid flow from DAC donars (current US$) of Mali in 1978 to that in 1982?
Keep it short and to the point. 0.95. What is the ratio of the Aid flow from DAC donars (current US$) of Rwanda in 1978 to that in 1982?
Offer a very short reply. 0.87. What is the ratio of the Aid flow from DAC donars (current US$) of Mali in 1979 to that in 1980?
Make the answer very short. 0.72. What is the ratio of the Aid flow from DAC donars (current US$) of Rwanda in 1979 to that in 1980?
Offer a terse response. 0.95. What is the ratio of the Aid flow from DAC donars (current US$) of Congo (Republic) in 1979 to that in 1981?
Your response must be concise. 1.32. What is the ratio of the Aid flow from DAC donars (current US$) of Mali in 1979 to that in 1981?
Offer a terse response. 0.79. What is the ratio of the Aid flow from DAC donars (current US$) of Rwanda in 1979 to that in 1981?
Give a very brief answer. 0.92. What is the ratio of the Aid flow from DAC donars (current US$) in Congo (Republic) in 1979 to that in 1982?
Your answer should be very brief. 1.02. What is the ratio of the Aid flow from DAC donars (current US$) of Mali in 1979 to that in 1982?
Your response must be concise. 1.09. What is the ratio of the Aid flow from DAC donars (current US$) of Rwanda in 1979 to that in 1982?
Your response must be concise. 0.97. What is the ratio of the Aid flow from DAC donars (current US$) of Congo (Republic) in 1980 to that in 1981?
Offer a very short reply. 1.32. What is the ratio of the Aid flow from DAC donars (current US$) of Mali in 1980 to that in 1981?
Your answer should be compact. 1.09. What is the ratio of the Aid flow from DAC donars (current US$) in Rwanda in 1980 to that in 1981?
Offer a very short reply. 0.97. What is the ratio of the Aid flow from DAC donars (current US$) of Congo (Republic) in 1980 to that in 1982?
Make the answer very short. 1.02. What is the ratio of the Aid flow from DAC donars (current US$) of Mali in 1980 to that in 1982?
Keep it short and to the point. 1.5. What is the ratio of the Aid flow from DAC donars (current US$) in Rwanda in 1980 to that in 1982?
Provide a short and direct response. 1.02. What is the ratio of the Aid flow from DAC donars (current US$) of Congo (Republic) in 1981 to that in 1982?
Provide a succinct answer. 0.78. What is the ratio of the Aid flow from DAC donars (current US$) in Mali in 1981 to that in 1982?
Make the answer very short. 1.38. What is the ratio of the Aid flow from DAC donars (current US$) in Rwanda in 1981 to that in 1982?
Your answer should be very brief. 1.05. What is the difference between the highest and the second highest Aid flow from DAC donars (current US$) of Congo (Republic)?
Make the answer very short. 2.00e+04. What is the difference between the highest and the second highest Aid flow from DAC donars (current US$) in Mali?
Provide a short and direct response. 1.47e+07. What is the difference between the highest and the second highest Aid flow from DAC donars (current US$) in Rwanda?
Offer a very short reply. 4.19e+06. What is the difference between the highest and the lowest Aid flow from DAC donars (current US$) in Congo (Republic)?
Provide a succinct answer. 2.44e+07. What is the difference between the highest and the lowest Aid flow from DAC donars (current US$) of Mali?
Make the answer very short. 1.11e+08. What is the difference between the highest and the lowest Aid flow from DAC donars (current US$) of Rwanda?
Make the answer very short. 5.75e+07. 